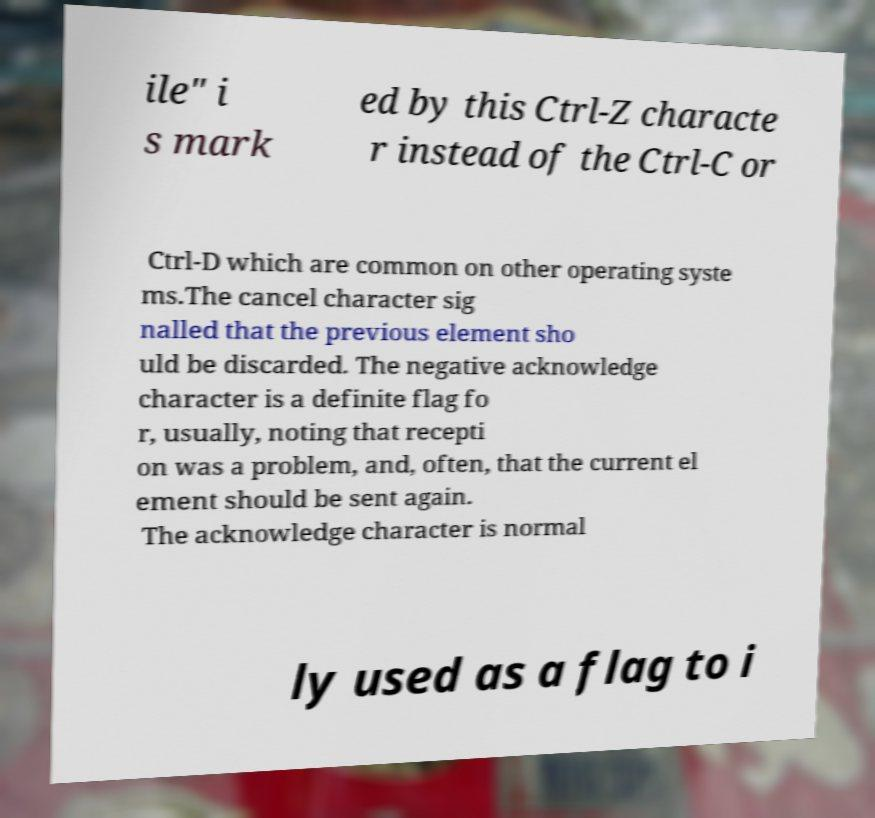Could you assist in decoding the text presented in this image and type it out clearly? ile" i s mark ed by this Ctrl-Z characte r instead of the Ctrl-C or Ctrl-D which are common on other operating syste ms.The cancel character sig nalled that the previous element sho uld be discarded. The negative acknowledge character is a definite flag fo r, usually, noting that recepti on was a problem, and, often, that the current el ement should be sent again. The acknowledge character is normal ly used as a flag to i 